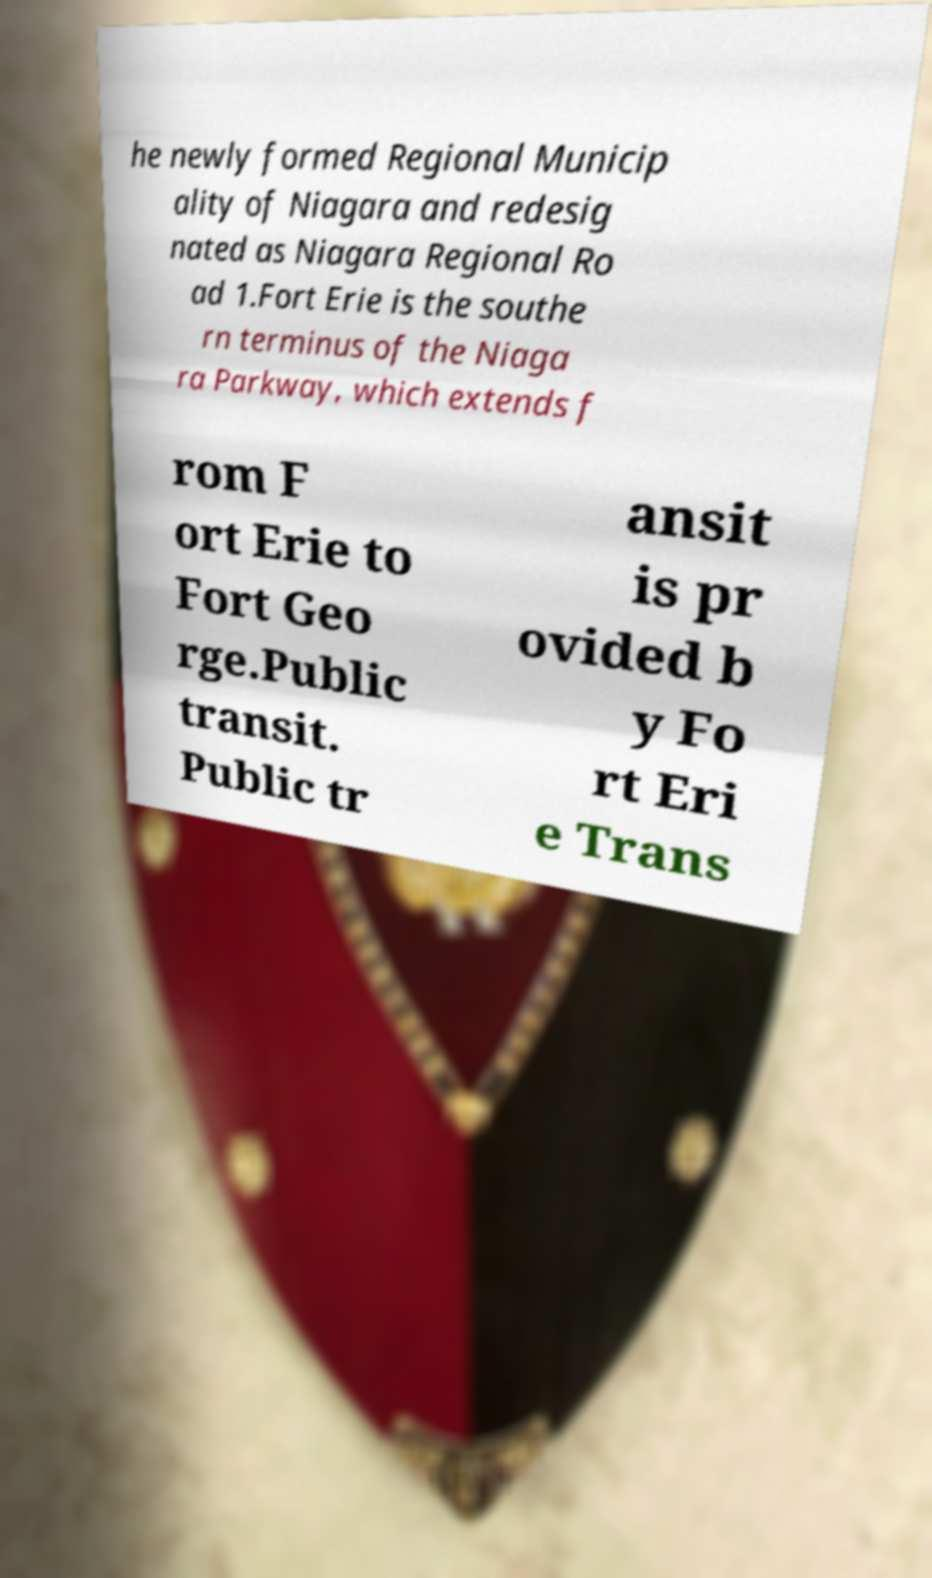Could you assist in decoding the text presented in this image and type it out clearly? he newly formed Regional Municip ality of Niagara and redesig nated as Niagara Regional Ro ad 1.Fort Erie is the southe rn terminus of the Niaga ra Parkway, which extends f rom F ort Erie to Fort Geo rge.Public transit. Public tr ansit is pr ovided b y Fo rt Eri e Trans 